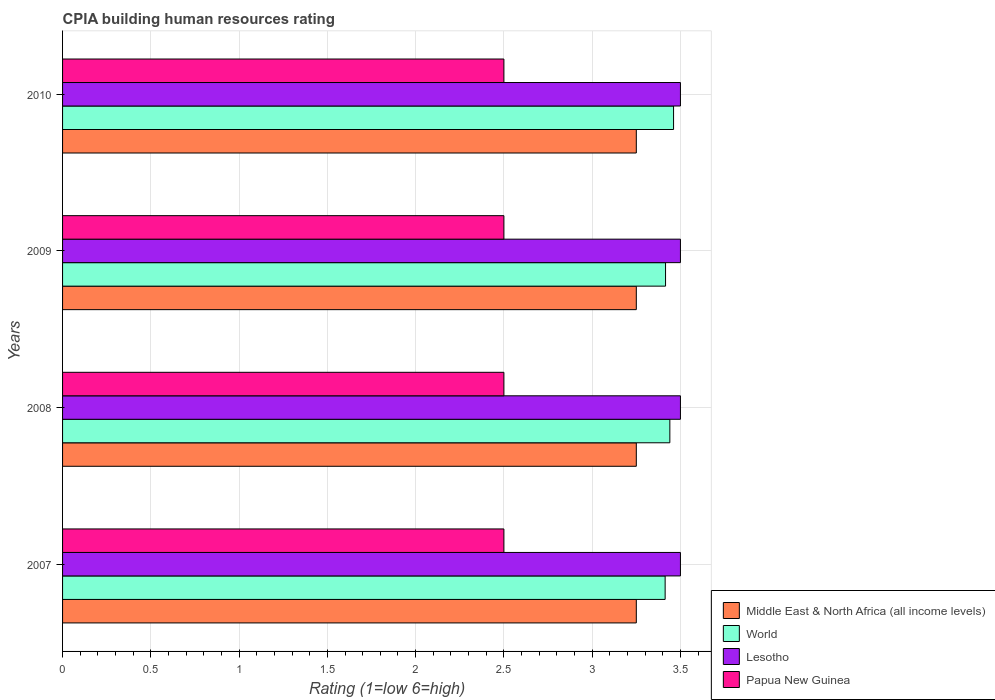How many different coloured bars are there?
Provide a short and direct response. 4. How many groups of bars are there?
Your answer should be compact. 4. In how many cases, is the number of bars for a given year not equal to the number of legend labels?
Offer a very short reply. 0. Across all years, what is the maximum CPIA rating in Papua New Guinea?
Your answer should be compact. 2.5. Across all years, what is the minimum CPIA rating in World?
Offer a terse response. 3.41. In which year was the CPIA rating in World maximum?
Provide a short and direct response. 2010. In which year was the CPIA rating in Papua New Guinea minimum?
Offer a terse response. 2007. What is the total CPIA rating in Lesotho in the graph?
Offer a terse response. 14. What is the difference between the CPIA rating in Middle East & North Africa (all income levels) in 2007 and that in 2009?
Keep it short and to the point. 0. What is the difference between the CPIA rating in Lesotho in 2010 and the CPIA rating in World in 2009?
Offer a very short reply. 0.08. What is the average CPIA rating in World per year?
Provide a succinct answer. 3.43. In the year 2008, what is the difference between the CPIA rating in World and CPIA rating in Middle East & North Africa (all income levels)?
Your answer should be very brief. 0.19. In how many years, is the CPIA rating in Lesotho greater than 0.9 ?
Provide a succinct answer. 4. What is the ratio of the CPIA rating in Papua New Guinea in 2007 to that in 2008?
Offer a terse response. 1. Is the CPIA rating in World in 2007 less than that in 2010?
Offer a terse response. Yes. Is the difference between the CPIA rating in World in 2008 and 2010 greater than the difference between the CPIA rating in Middle East & North Africa (all income levels) in 2008 and 2010?
Provide a short and direct response. No. What is the difference between the highest and the second highest CPIA rating in Middle East & North Africa (all income levels)?
Ensure brevity in your answer.  0. What is the difference between the highest and the lowest CPIA rating in Lesotho?
Keep it short and to the point. 0. In how many years, is the CPIA rating in Middle East & North Africa (all income levels) greater than the average CPIA rating in Middle East & North Africa (all income levels) taken over all years?
Make the answer very short. 0. What does the 4th bar from the top in 2009 represents?
Give a very brief answer. Middle East & North Africa (all income levels). What does the 1st bar from the bottom in 2009 represents?
Provide a succinct answer. Middle East & North Africa (all income levels). Is it the case that in every year, the sum of the CPIA rating in Middle East & North Africa (all income levels) and CPIA rating in World is greater than the CPIA rating in Lesotho?
Your answer should be compact. Yes. Does the graph contain grids?
Provide a succinct answer. Yes. Where does the legend appear in the graph?
Your answer should be very brief. Bottom right. How many legend labels are there?
Ensure brevity in your answer.  4. What is the title of the graph?
Your answer should be compact. CPIA building human resources rating. Does "New Zealand" appear as one of the legend labels in the graph?
Offer a terse response. No. What is the Rating (1=low 6=high) in World in 2007?
Your response must be concise. 3.41. What is the Rating (1=low 6=high) of World in 2008?
Offer a terse response. 3.44. What is the Rating (1=low 6=high) of Papua New Guinea in 2008?
Give a very brief answer. 2.5. What is the Rating (1=low 6=high) in Middle East & North Africa (all income levels) in 2009?
Make the answer very short. 3.25. What is the Rating (1=low 6=high) in World in 2009?
Your answer should be compact. 3.42. What is the Rating (1=low 6=high) in Papua New Guinea in 2009?
Keep it short and to the point. 2.5. What is the Rating (1=low 6=high) of World in 2010?
Your answer should be compact. 3.46. Across all years, what is the maximum Rating (1=low 6=high) in Middle East & North Africa (all income levels)?
Your answer should be very brief. 3.25. Across all years, what is the maximum Rating (1=low 6=high) in World?
Your answer should be very brief. 3.46. Across all years, what is the minimum Rating (1=low 6=high) in World?
Your response must be concise. 3.41. Across all years, what is the minimum Rating (1=low 6=high) of Lesotho?
Give a very brief answer. 3.5. Across all years, what is the minimum Rating (1=low 6=high) of Papua New Guinea?
Your answer should be very brief. 2.5. What is the total Rating (1=low 6=high) in World in the graph?
Your answer should be very brief. 13.73. What is the total Rating (1=low 6=high) in Lesotho in the graph?
Offer a very short reply. 14. What is the difference between the Rating (1=low 6=high) in World in 2007 and that in 2008?
Make the answer very short. -0.03. What is the difference between the Rating (1=low 6=high) of Lesotho in 2007 and that in 2008?
Give a very brief answer. 0. What is the difference between the Rating (1=low 6=high) of World in 2007 and that in 2009?
Your response must be concise. -0. What is the difference between the Rating (1=low 6=high) in Middle East & North Africa (all income levels) in 2007 and that in 2010?
Make the answer very short. 0. What is the difference between the Rating (1=low 6=high) in World in 2007 and that in 2010?
Ensure brevity in your answer.  -0.05. What is the difference between the Rating (1=low 6=high) in World in 2008 and that in 2009?
Your answer should be very brief. 0.02. What is the difference between the Rating (1=low 6=high) in Papua New Guinea in 2008 and that in 2009?
Your answer should be compact. 0. What is the difference between the Rating (1=low 6=high) in Middle East & North Africa (all income levels) in 2008 and that in 2010?
Offer a terse response. 0. What is the difference between the Rating (1=low 6=high) of World in 2008 and that in 2010?
Make the answer very short. -0.02. What is the difference between the Rating (1=low 6=high) in Lesotho in 2008 and that in 2010?
Make the answer very short. 0. What is the difference between the Rating (1=low 6=high) in Middle East & North Africa (all income levels) in 2009 and that in 2010?
Provide a succinct answer. 0. What is the difference between the Rating (1=low 6=high) in World in 2009 and that in 2010?
Give a very brief answer. -0.05. What is the difference between the Rating (1=low 6=high) of Lesotho in 2009 and that in 2010?
Make the answer very short. 0. What is the difference between the Rating (1=low 6=high) of Papua New Guinea in 2009 and that in 2010?
Offer a very short reply. 0. What is the difference between the Rating (1=low 6=high) in Middle East & North Africa (all income levels) in 2007 and the Rating (1=low 6=high) in World in 2008?
Give a very brief answer. -0.19. What is the difference between the Rating (1=low 6=high) in Middle East & North Africa (all income levels) in 2007 and the Rating (1=low 6=high) in Lesotho in 2008?
Your answer should be very brief. -0.25. What is the difference between the Rating (1=low 6=high) in World in 2007 and the Rating (1=low 6=high) in Lesotho in 2008?
Provide a succinct answer. -0.09. What is the difference between the Rating (1=low 6=high) in World in 2007 and the Rating (1=low 6=high) in Papua New Guinea in 2008?
Make the answer very short. 0.91. What is the difference between the Rating (1=low 6=high) in Lesotho in 2007 and the Rating (1=low 6=high) in Papua New Guinea in 2008?
Provide a short and direct response. 1. What is the difference between the Rating (1=low 6=high) in Middle East & North Africa (all income levels) in 2007 and the Rating (1=low 6=high) in World in 2009?
Give a very brief answer. -0.17. What is the difference between the Rating (1=low 6=high) in Middle East & North Africa (all income levels) in 2007 and the Rating (1=low 6=high) in Papua New Guinea in 2009?
Your response must be concise. 0.75. What is the difference between the Rating (1=low 6=high) of World in 2007 and the Rating (1=low 6=high) of Lesotho in 2009?
Offer a terse response. -0.09. What is the difference between the Rating (1=low 6=high) in World in 2007 and the Rating (1=low 6=high) in Papua New Guinea in 2009?
Offer a very short reply. 0.91. What is the difference between the Rating (1=low 6=high) of Middle East & North Africa (all income levels) in 2007 and the Rating (1=low 6=high) of World in 2010?
Provide a succinct answer. -0.21. What is the difference between the Rating (1=low 6=high) of Middle East & North Africa (all income levels) in 2007 and the Rating (1=low 6=high) of Lesotho in 2010?
Offer a very short reply. -0.25. What is the difference between the Rating (1=low 6=high) in World in 2007 and the Rating (1=low 6=high) in Lesotho in 2010?
Give a very brief answer. -0.09. What is the difference between the Rating (1=low 6=high) of World in 2007 and the Rating (1=low 6=high) of Papua New Guinea in 2010?
Your answer should be very brief. 0.91. What is the difference between the Rating (1=low 6=high) in Lesotho in 2007 and the Rating (1=low 6=high) in Papua New Guinea in 2010?
Keep it short and to the point. 1. What is the difference between the Rating (1=low 6=high) of Middle East & North Africa (all income levels) in 2008 and the Rating (1=low 6=high) of World in 2009?
Your response must be concise. -0.17. What is the difference between the Rating (1=low 6=high) of Middle East & North Africa (all income levels) in 2008 and the Rating (1=low 6=high) of Papua New Guinea in 2009?
Give a very brief answer. 0.75. What is the difference between the Rating (1=low 6=high) of World in 2008 and the Rating (1=low 6=high) of Lesotho in 2009?
Keep it short and to the point. -0.06. What is the difference between the Rating (1=low 6=high) in Lesotho in 2008 and the Rating (1=low 6=high) in Papua New Guinea in 2009?
Make the answer very short. 1. What is the difference between the Rating (1=low 6=high) of Middle East & North Africa (all income levels) in 2008 and the Rating (1=low 6=high) of World in 2010?
Offer a terse response. -0.21. What is the difference between the Rating (1=low 6=high) in Middle East & North Africa (all income levels) in 2008 and the Rating (1=low 6=high) in Papua New Guinea in 2010?
Keep it short and to the point. 0.75. What is the difference between the Rating (1=low 6=high) in World in 2008 and the Rating (1=low 6=high) in Lesotho in 2010?
Your answer should be compact. -0.06. What is the difference between the Rating (1=low 6=high) of Middle East & North Africa (all income levels) in 2009 and the Rating (1=low 6=high) of World in 2010?
Offer a terse response. -0.21. What is the difference between the Rating (1=low 6=high) of Middle East & North Africa (all income levels) in 2009 and the Rating (1=low 6=high) of Lesotho in 2010?
Provide a short and direct response. -0.25. What is the difference between the Rating (1=low 6=high) in Middle East & North Africa (all income levels) in 2009 and the Rating (1=low 6=high) in Papua New Guinea in 2010?
Give a very brief answer. 0.75. What is the difference between the Rating (1=low 6=high) of World in 2009 and the Rating (1=low 6=high) of Lesotho in 2010?
Provide a short and direct response. -0.08. What is the difference between the Rating (1=low 6=high) of World in 2009 and the Rating (1=low 6=high) of Papua New Guinea in 2010?
Give a very brief answer. 0.92. What is the difference between the Rating (1=low 6=high) in Lesotho in 2009 and the Rating (1=low 6=high) in Papua New Guinea in 2010?
Keep it short and to the point. 1. What is the average Rating (1=low 6=high) of World per year?
Your response must be concise. 3.43. What is the average Rating (1=low 6=high) of Lesotho per year?
Offer a very short reply. 3.5. What is the average Rating (1=low 6=high) of Papua New Guinea per year?
Provide a short and direct response. 2.5. In the year 2007, what is the difference between the Rating (1=low 6=high) of Middle East & North Africa (all income levels) and Rating (1=low 6=high) of World?
Offer a terse response. -0.16. In the year 2007, what is the difference between the Rating (1=low 6=high) in Middle East & North Africa (all income levels) and Rating (1=low 6=high) in Lesotho?
Provide a short and direct response. -0.25. In the year 2007, what is the difference between the Rating (1=low 6=high) of Middle East & North Africa (all income levels) and Rating (1=low 6=high) of Papua New Guinea?
Give a very brief answer. 0.75. In the year 2007, what is the difference between the Rating (1=low 6=high) of World and Rating (1=low 6=high) of Lesotho?
Offer a terse response. -0.09. In the year 2007, what is the difference between the Rating (1=low 6=high) in World and Rating (1=low 6=high) in Papua New Guinea?
Your response must be concise. 0.91. In the year 2008, what is the difference between the Rating (1=low 6=high) in Middle East & North Africa (all income levels) and Rating (1=low 6=high) in World?
Ensure brevity in your answer.  -0.19. In the year 2008, what is the difference between the Rating (1=low 6=high) of Middle East & North Africa (all income levels) and Rating (1=low 6=high) of Lesotho?
Give a very brief answer. -0.25. In the year 2008, what is the difference between the Rating (1=low 6=high) of World and Rating (1=low 6=high) of Lesotho?
Ensure brevity in your answer.  -0.06. In the year 2008, what is the difference between the Rating (1=low 6=high) in World and Rating (1=low 6=high) in Papua New Guinea?
Ensure brevity in your answer.  0.94. In the year 2009, what is the difference between the Rating (1=low 6=high) of Middle East & North Africa (all income levels) and Rating (1=low 6=high) of World?
Provide a short and direct response. -0.17. In the year 2009, what is the difference between the Rating (1=low 6=high) of Middle East & North Africa (all income levels) and Rating (1=low 6=high) of Lesotho?
Your answer should be compact. -0.25. In the year 2009, what is the difference between the Rating (1=low 6=high) in Middle East & North Africa (all income levels) and Rating (1=low 6=high) in Papua New Guinea?
Provide a succinct answer. 0.75. In the year 2009, what is the difference between the Rating (1=low 6=high) in World and Rating (1=low 6=high) in Lesotho?
Provide a short and direct response. -0.08. In the year 2009, what is the difference between the Rating (1=low 6=high) in World and Rating (1=low 6=high) in Papua New Guinea?
Make the answer very short. 0.92. In the year 2010, what is the difference between the Rating (1=low 6=high) of Middle East & North Africa (all income levels) and Rating (1=low 6=high) of World?
Provide a short and direct response. -0.21. In the year 2010, what is the difference between the Rating (1=low 6=high) in World and Rating (1=low 6=high) in Lesotho?
Provide a short and direct response. -0.04. What is the ratio of the Rating (1=low 6=high) of World in 2007 to that in 2008?
Your answer should be very brief. 0.99. What is the ratio of the Rating (1=low 6=high) in World in 2007 to that in 2009?
Your response must be concise. 1. What is the ratio of the Rating (1=low 6=high) of Lesotho in 2007 to that in 2009?
Keep it short and to the point. 1. What is the ratio of the Rating (1=low 6=high) in World in 2007 to that in 2010?
Keep it short and to the point. 0.99. What is the ratio of the Rating (1=low 6=high) of Lesotho in 2007 to that in 2010?
Ensure brevity in your answer.  1. What is the ratio of the Rating (1=low 6=high) of Papua New Guinea in 2007 to that in 2010?
Your answer should be very brief. 1. What is the ratio of the Rating (1=low 6=high) of World in 2008 to that in 2009?
Give a very brief answer. 1.01. What is the ratio of the Rating (1=low 6=high) in World in 2008 to that in 2010?
Your response must be concise. 0.99. What is the ratio of the Rating (1=low 6=high) of Lesotho in 2008 to that in 2010?
Keep it short and to the point. 1. What is the ratio of the Rating (1=low 6=high) in World in 2009 to that in 2010?
Keep it short and to the point. 0.99. What is the ratio of the Rating (1=low 6=high) of Lesotho in 2009 to that in 2010?
Give a very brief answer. 1. What is the ratio of the Rating (1=low 6=high) in Papua New Guinea in 2009 to that in 2010?
Give a very brief answer. 1. What is the difference between the highest and the second highest Rating (1=low 6=high) of Middle East & North Africa (all income levels)?
Your answer should be compact. 0. What is the difference between the highest and the second highest Rating (1=low 6=high) of World?
Make the answer very short. 0.02. What is the difference between the highest and the second highest Rating (1=low 6=high) in Lesotho?
Offer a very short reply. 0. What is the difference between the highest and the second highest Rating (1=low 6=high) in Papua New Guinea?
Provide a short and direct response. 0. What is the difference between the highest and the lowest Rating (1=low 6=high) in World?
Offer a terse response. 0.05. What is the difference between the highest and the lowest Rating (1=low 6=high) in Lesotho?
Give a very brief answer. 0. What is the difference between the highest and the lowest Rating (1=low 6=high) in Papua New Guinea?
Provide a succinct answer. 0. 